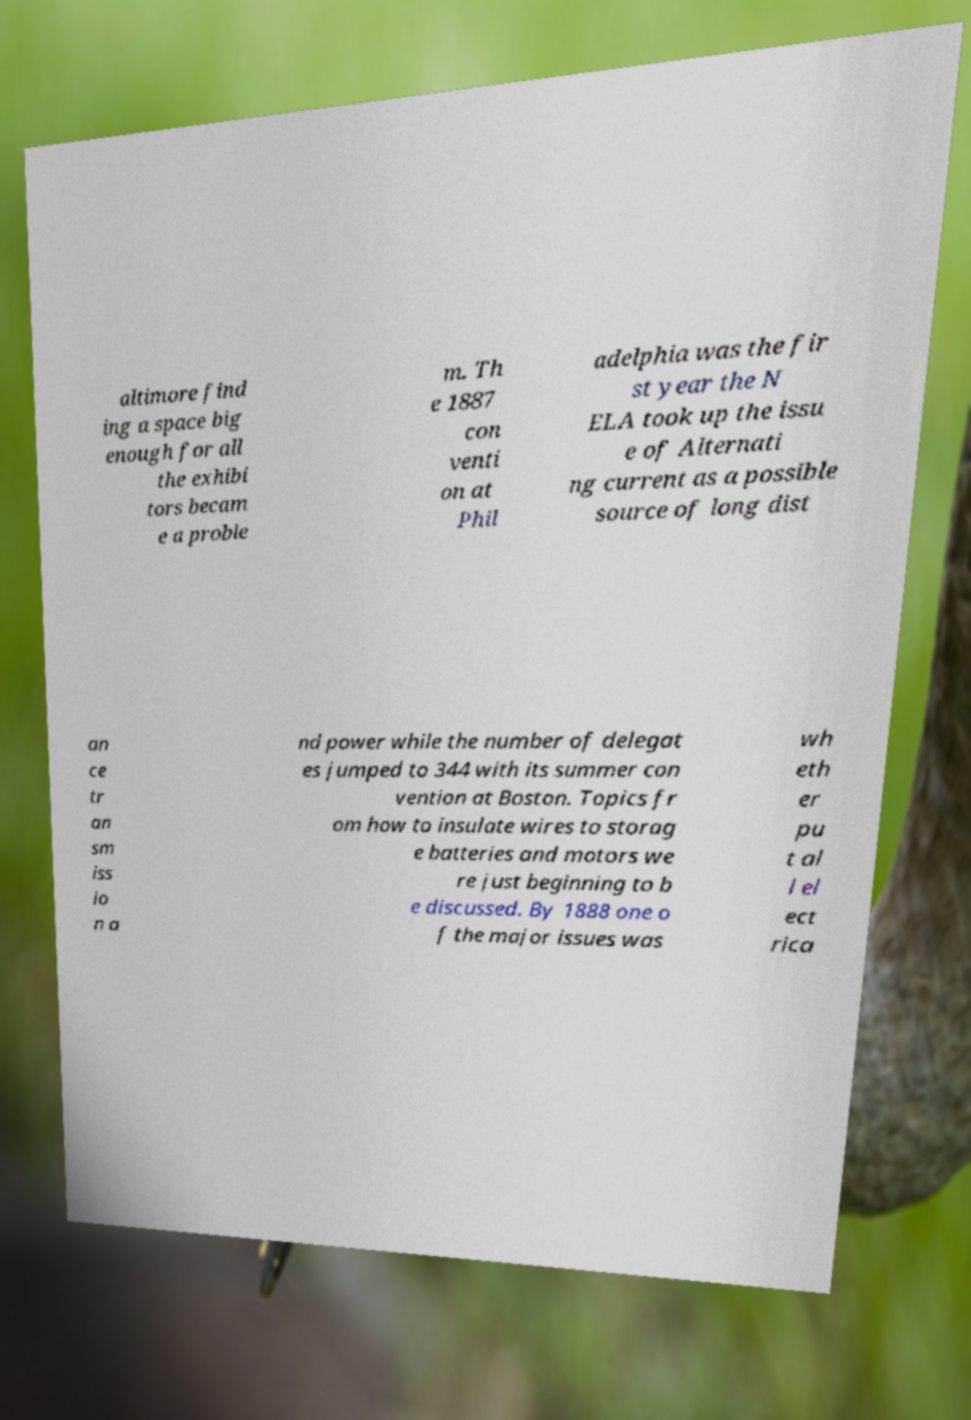I need the written content from this picture converted into text. Can you do that? altimore find ing a space big enough for all the exhibi tors becam e a proble m. Th e 1887 con venti on at Phil adelphia was the fir st year the N ELA took up the issu e of Alternati ng current as a possible source of long dist an ce tr an sm iss io n a nd power while the number of delegat es jumped to 344 with its summer con vention at Boston. Topics fr om how to insulate wires to storag e batteries and motors we re just beginning to b e discussed. By 1888 one o f the major issues was wh eth er pu t al l el ect rica 